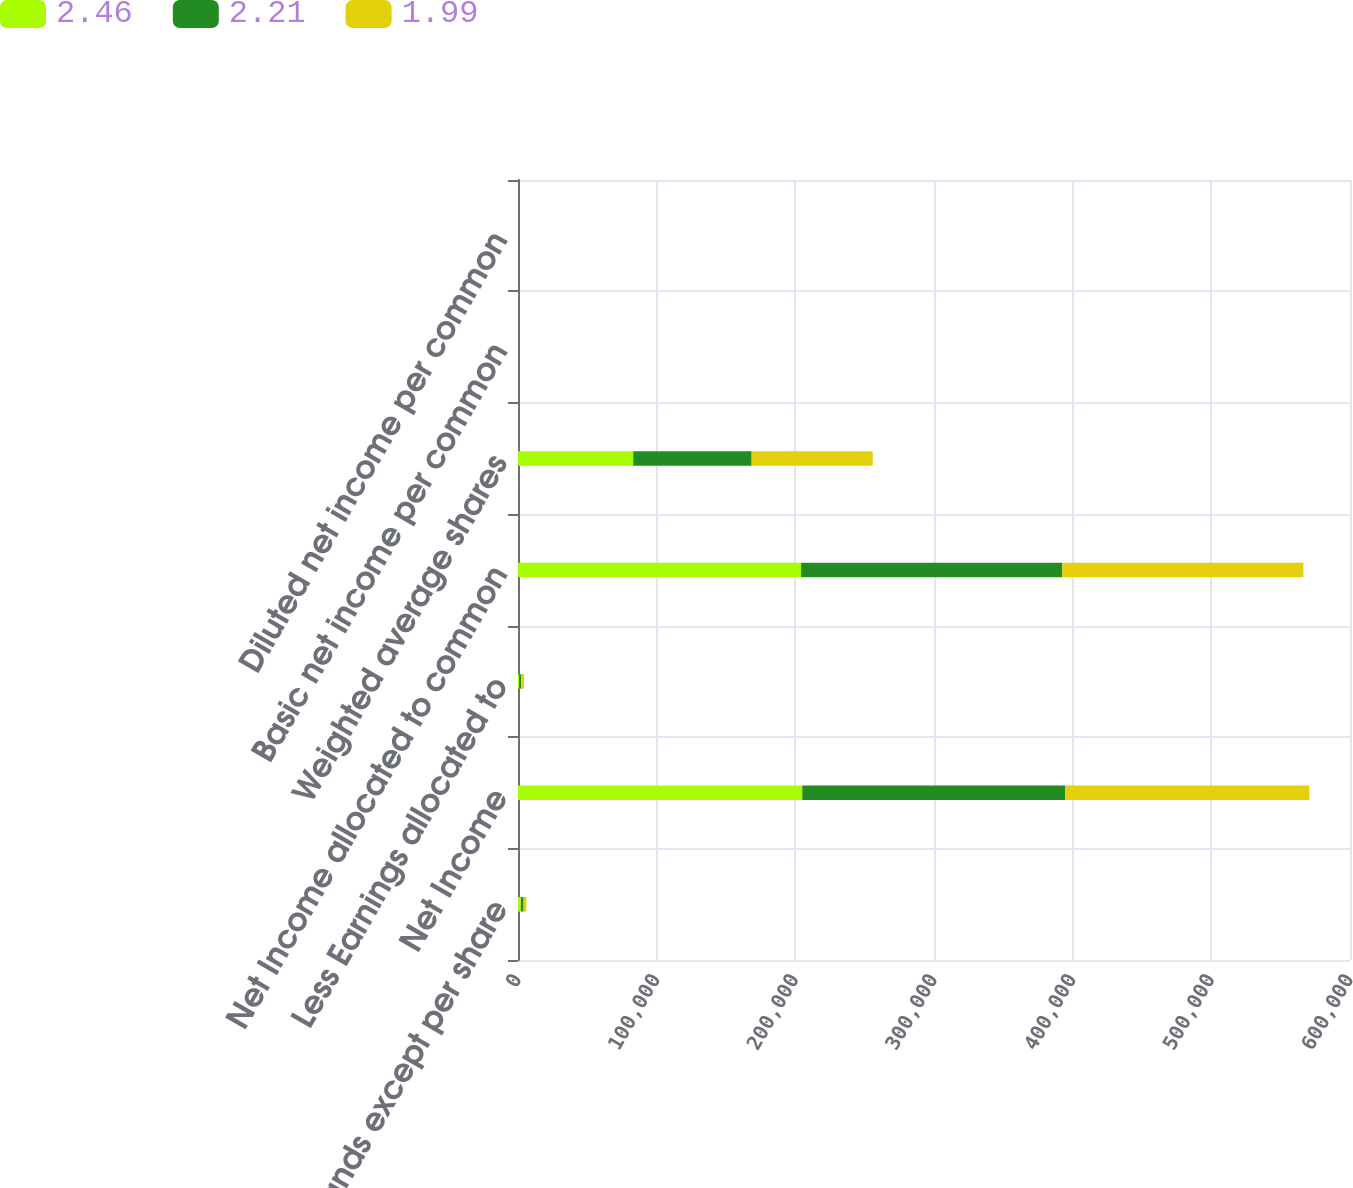<chart> <loc_0><loc_0><loc_500><loc_500><stacked_bar_chart><ecel><fcel>(in thousands except per share<fcel>Net Income<fcel>Less Earnings allocated to<fcel>Net Income allocated to common<fcel>Weighted average shares<fcel>Basic net income per common<fcel>Diluted net income per common<nl><fcel>2.46<fcel>2015<fcel>205023<fcel>898<fcel>204125<fcel>83081<fcel>2.46<fcel>2.46<nl><fcel>2.21<fcel>2014<fcel>189714<fcel>1322<fcel>188392<fcel>85406<fcel>2.21<fcel>2.21<nl><fcel>1.99<fcel>2013<fcel>175999<fcel>2136<fcel>173863<fcel>87331<fcel>1.99<fcel>1.99<nl></chart> 